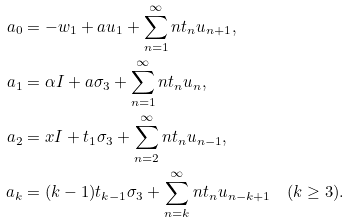Convert formula to latex. <formula><loc_0><loc_0><loc_500><loc_500>a _ { 0 } & = - w _ { 1 } + a u _ { 1 } + \sum _ { n = 1 } ^ { \infty } n t _ { n } u _ { n + 1 } , \\ a _ { 1 } & = \alpha I + a \sigma _ { 3 } + \sum _ { n = 1 } ^ { \infty } n t _ { n } u _ { n } , \\ a _ { 2 } & = x I + t _ { 1 } \sigma _ { 3 } + \sum _ { n = 2 } ^ { \infty } n t _ { n } u _ { n - 1 } , \\ a _ { k } & = ( k - 1 ) t _ { k - 1 } \sigma _ { 3 } + \sum _ { n = k } ^ { \infty } n t _ { n } u _ { n - k + 1 } \quad ( k \geq 3 ) .</formula> 